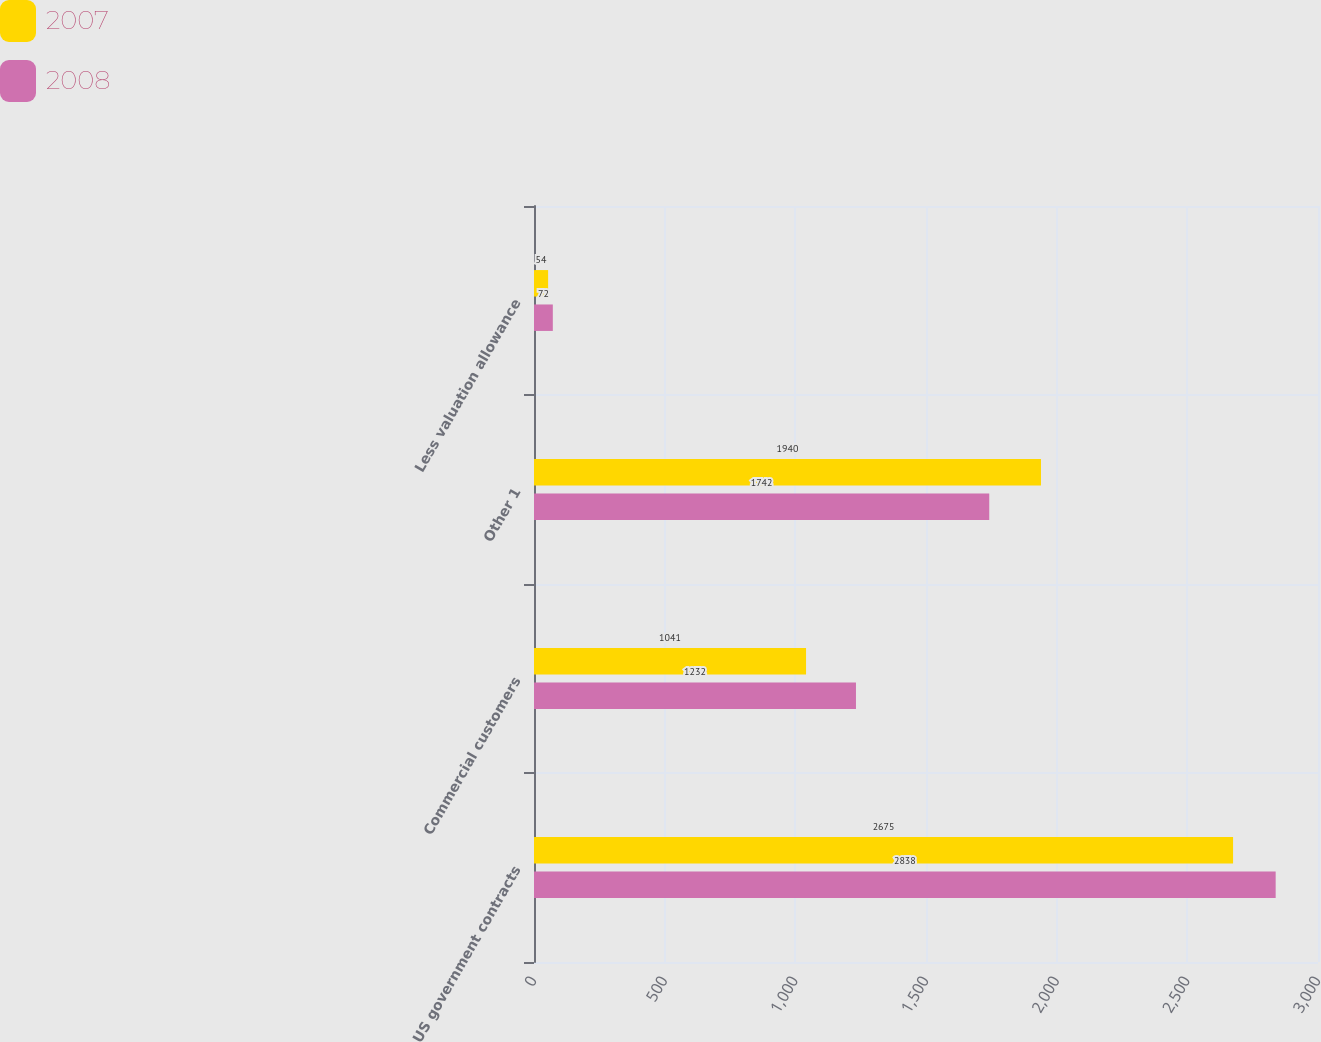Convert chart to OTSL. <chart><loc_0><loc_0><loc_500><loc_500><stacked_bar_chart><ecel><fcel>US government contracts<fcel>Commercial customers<fcel>Other 1<fcel>Less valuation allowance<nl><fcel>2007<fcel>2675<fcel>1041<fcel>1940<fcel>54<nl><fcel>2008<fcel>2838<fcel>1232<fcel>1742<fcel>72<nl></chart> 